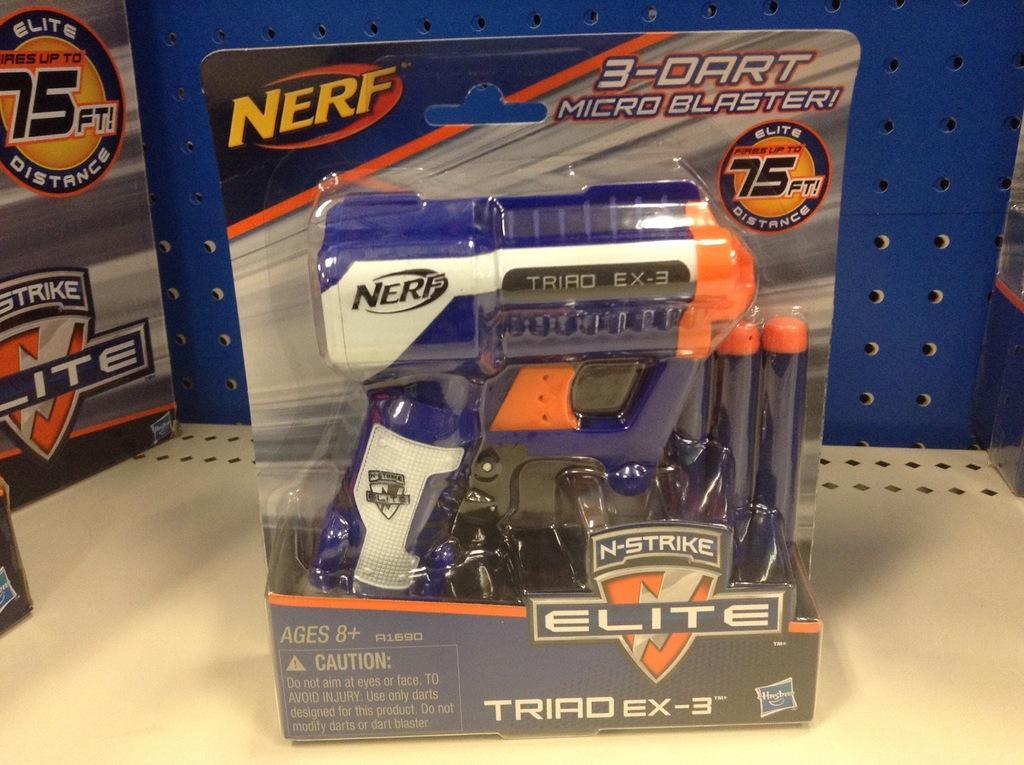Can you describe this image briefly? At the bottom of the match table. In the background there is a wooden surface. In the middle of the image there is a toy in the packet and there is a text on the packet. On the left side of the image there is a board with a text on it. 